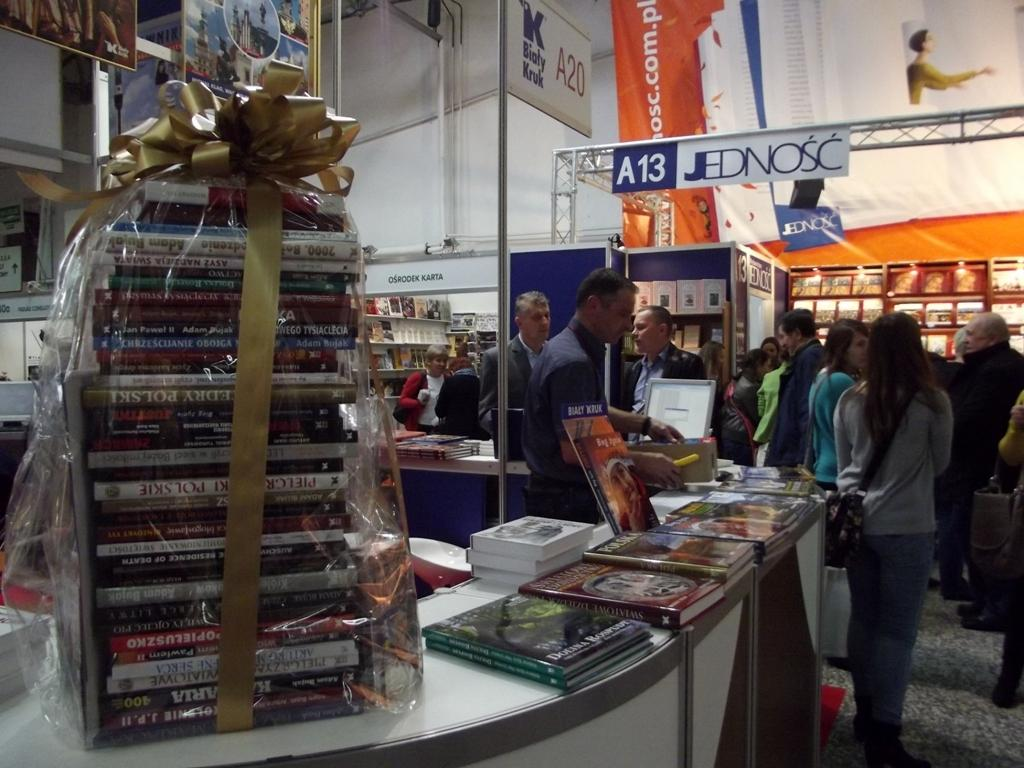<image>
Present a compact description of the photo's key features. the letter A is on a blue sign with the number 13 next to it 